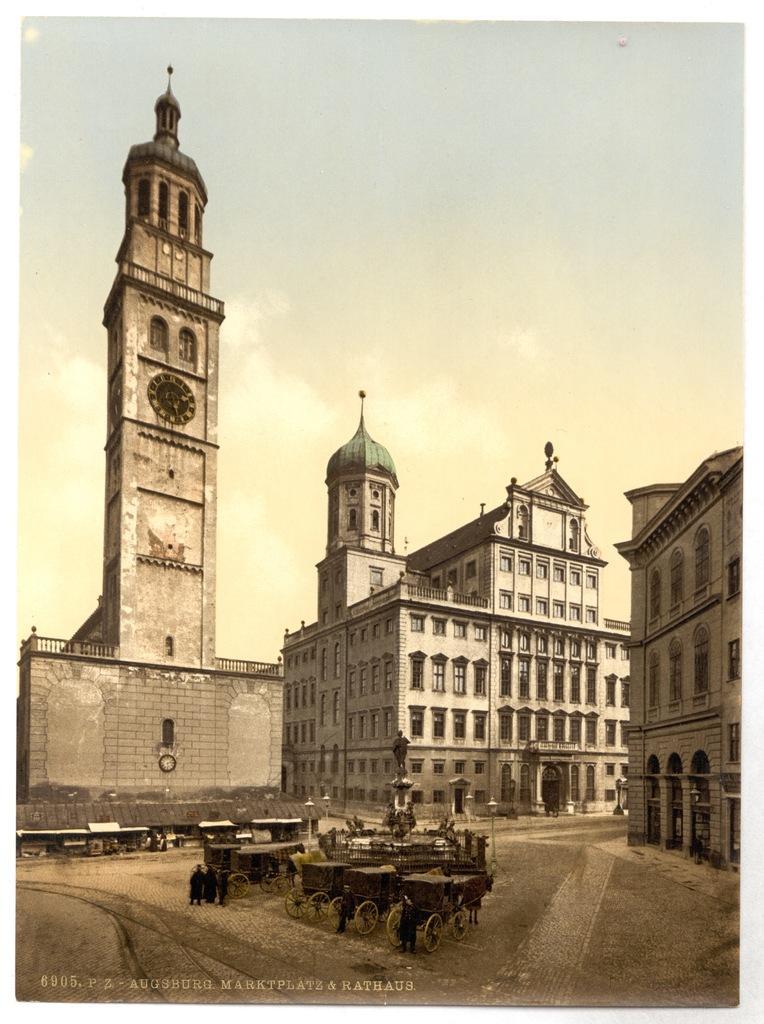In one or two sentences, can you explain what this image depicts? This is the black and white image, where there are horse carts in the middle of the road. In the background, there are buildings, a sculpture, few light poles and the sky. 